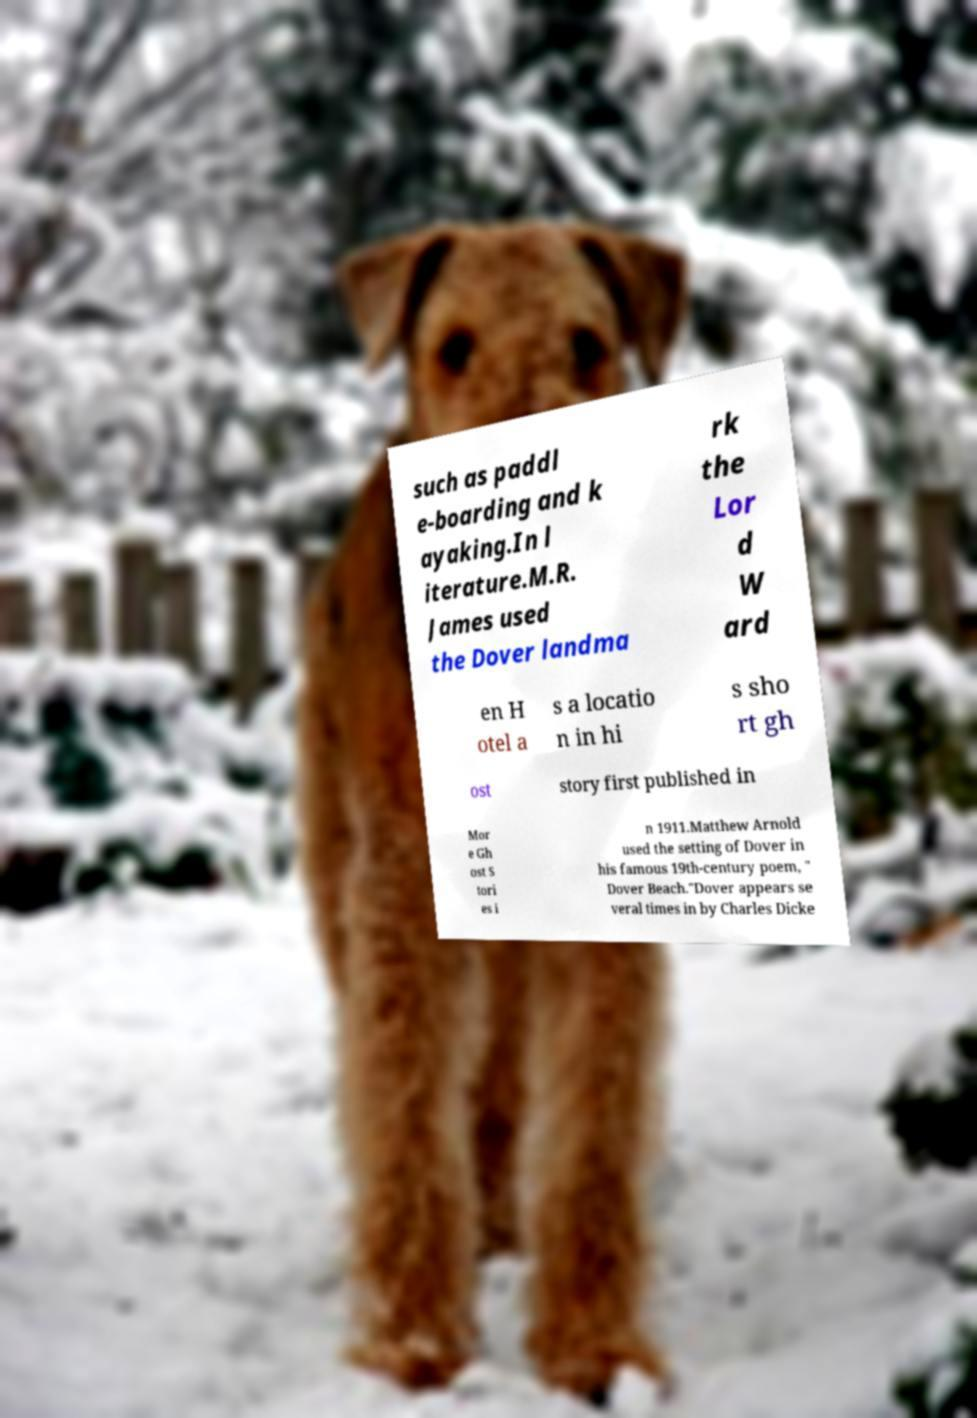What messages or text are displayed in this image? I need them in a readable, typed format. such as paddl e-boarding and k ayaking.In l iterature.M.R. James used the Dover landma rk the Lor d W ard en H otel a s a locatio n in hi s sho rt gh ost story first published in Mor e Gh ost S tori es i n 1911.Matthew Arnold used the setting of Dover in his famous 19th-century poem, " Dover Beach."Dover appears se veral times in by Charles Dicke 